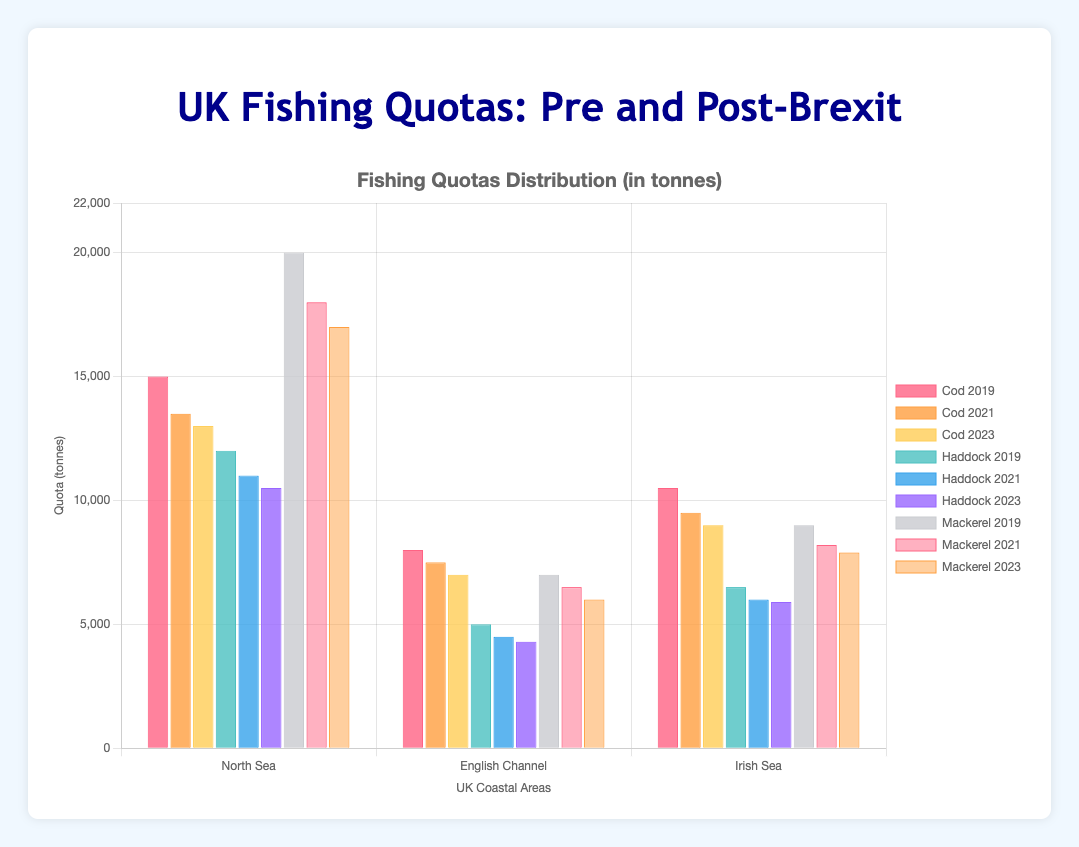What was the total cod quota for the North Sea, English Channel, and Irish Sea combined in 2019? To determine the total cod quota for these regions in 2019, sum the cod quotas for each region: 15000 (North Sea) + 8000 (English Channel) + 10500 (Irish Sea) = 33500 tonnes.
Answer: 33500 tonnes Which year had the highest mackerel quota in the North Sea? By examining the bars representing mackerel quotas for the North Sea across different years, the 2019 value is the highest at 20000 tonnes, compared to 18000 tonnes in 2021 and 17000 tonnes in 2023.
Answer: 2019 How did the haddock quota in the English Channel change from 2019 to 2023? To find the change in haddock quota, subtract the 2023 quota (4300 tonnes) from the 2019 quota (5000 tonnes): 5000 - 4300 = 700 tonnes reduction.
Answer: 700 tonnes reduction Which region had the least mackerel quota in 2021? By comparing the heights of the bars representing mackerel quotas in 2021, the English Channel had the lowest value at 6500 tonnes, compared to the North Sea (18000 tonnes) and Irish Sea (8200 tonnes).
Answer: English Channel What’s the combined quota of haddock and mackerel in the Irish Sea for the year 2023? Sum the haddock quota (5900 tonnes) and the mackerel quota (7900 tonnes) for the Irish Sea in 2023: 5900 + 7900 = 13800 tonnes.
Answer: 13800 tonnes Which fish species saw the most significant quota reduction in the North Sea from 2019 to 2023? Calculate the reduction for each species: Cod: 15000 - 13000 = 2000 tonnes, Haddock: 12000 - 10500 = 1500 tonnes, and Mackerel: 20000 - 17000 = 3000 tonnes. Mackerel experienced the largest reduction.
Answer: Mackerel What is the average cod quota across all regions in 2023? To calculate the average, sum the cod quotas in 2023 (13000 + 7000 + 9000) and divide by the number of regions (3): (13000 + 7000 + 9000) / 3 = 29000 / 3 ≈ 9667 tonnes.
Answer: 9667 tonnes Is the quota for haddock in the North Sea higher in 2023 than in 2021? Compare the bars for haddock quotas in the North Sea for 2023 (10500 tonnes) and 2021 (11000 tonnes). Since 10500 is less than 11000, the quota is lower in 2023.
Answer: No By how much did the cod quota in the Irish Sea decrease from 2019 to 2023? Calculate the decrease by subtracting the 2023 quota (9000 tonnes) from the 2019 quota (10500 tonnes): 10500 - 9000 = 1500 tonnes.
Answer: 1500 tonnes 